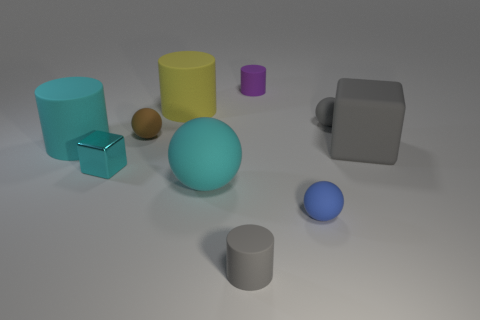Is there another matte thing that has the same shape as the yellow rubber object?
Ensure brevity in your answer.  Yes. Does the brown matte thing have the same size as the rubber thing to the left of the cyan metallic block?
Give a very brief answer. No. How many objects are either tiny balls that are right of the purple rubber thing or big cyan matte things that are to the left of the tiny gray cylinder?
Offer a very short reply. 4. Are there more gray matte blocks in front of the tiny brown matte sphere than big gray cubes?
Offer a terse response. No. What number of gray cylinders have the same size as the yellow rubber cylinder?
Make the answer very short. 0. Is the size of the gray object that is in front of the small shiny cube the same as the cube right of the small purple rubber object?
Your answer should be very brief. No. There is a blue object that is in front of the large cyan sphere; how big is it?
Your answer should be very brief. Small. There is a matte object behind the large yellow cylinder behind the cyan ball; what is its size?
Ensure brevity in your answer.  Small. There is a purple thing that is the same size as the gray cylinder; what material is it?
Offer a terse response. Rubber. Are there any brown matte objects behind the small gray ball?
Offer a terse response. No. 